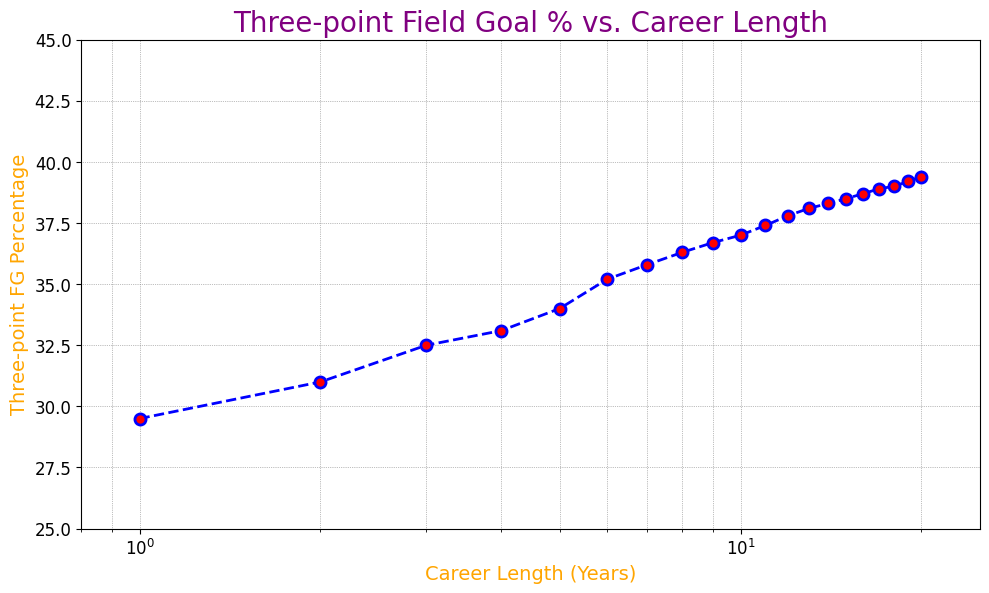What is the Three-point Field Goal (FG) Percentage for players with a career length of 10 years? Refer to the data point corresponding to a career length of 10 years on the x-axis and check the percentage value on the y-axis.
Answer: 37.0 How does the Three-point FG Percentage trend as career length increases from 1 year to 20 years? Observe the general direction of the line connecting the data points. The percentage increases steadily as the career length increases from 1 year to 20 years.
Answer: Increases Is there a more significant increase in Three-point FG Percentage in the first 10 years or the second 10 years of a player's career? Calculate the percentage increase for the first 10 years and the second 10 years. For the first 10 years, it's from 29.5% to 37.0%, an increase of 37.0 - 29.5 = 7.5%. For the second 10 years, it's from 37.0% to 39.4%, an increase of 39.4 - 37.0 = 2.4%.
Answer: First 10 years What is the Three-point FG Percentage difference between players with a career length of 5 years and those with a career length of 10 years? Find the percentage for 5 years (34.0%) and 10 years (37.0%). Then, subtract the two values: 37.0 - 34.0 = 3.0%.
Answer: 3.0% What visual elements highlight the career lengths on the x-axis? Identify the features used to represent the career length. The x-axis is labeled clearly with numbers representing career lengths in years, and markers (red dots) are used to highlight each data point.
Answer: Numbers and markers What visual technique is used to emphasize changes in career lengths on the x-axis? Notice the scale of the x-axis. A logarithmic scale is used, which makes it easier to see changes across wider ranges of career lengths.
Answer: Logarithmic scale If we look at players with a career length of 1 year versus 20 years, how much better do players with longer careers perform on three-point shots? Check the percentages for career lengths of 1 year (29.5%) and 20 years (39.4%). Then, compute the improvement: 39.4 - 29.5 = 9.9%.
Answer: 9.9% Which range of career lengths appears to have the highest increase in Three-point FG Percentage per year? Compare the slopes of the segments between data points. The biggest annual increase happens in the early years, from 1 year (29.5%) to 5 years (34.0%) because the relative increase is highest.
Answer: Early years (1-5 years) 